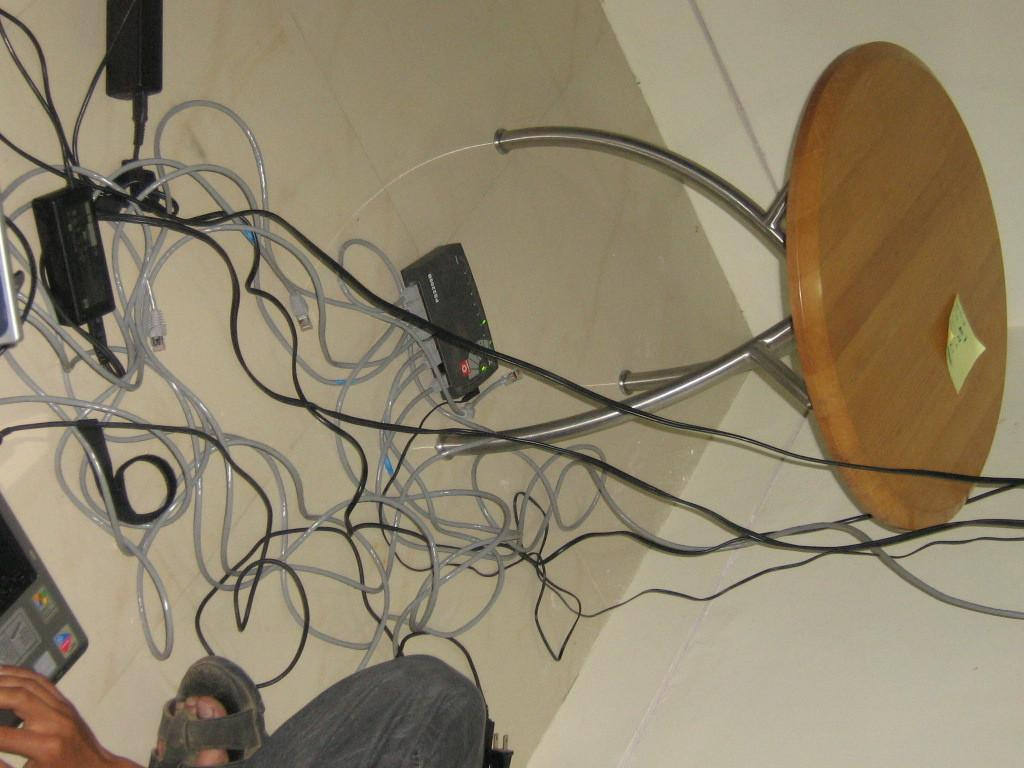Where is the person located in the image? The person is in the bottom left corner of the image. What is on the right side of the image? There is a table on the right side of the image. What can be found on the table? There are objects on the table. What is the condition of the discussion taking place in the image? There is no discussion taking place in the image, as it only shows a person in the bottom left corner and a table on the right side. 